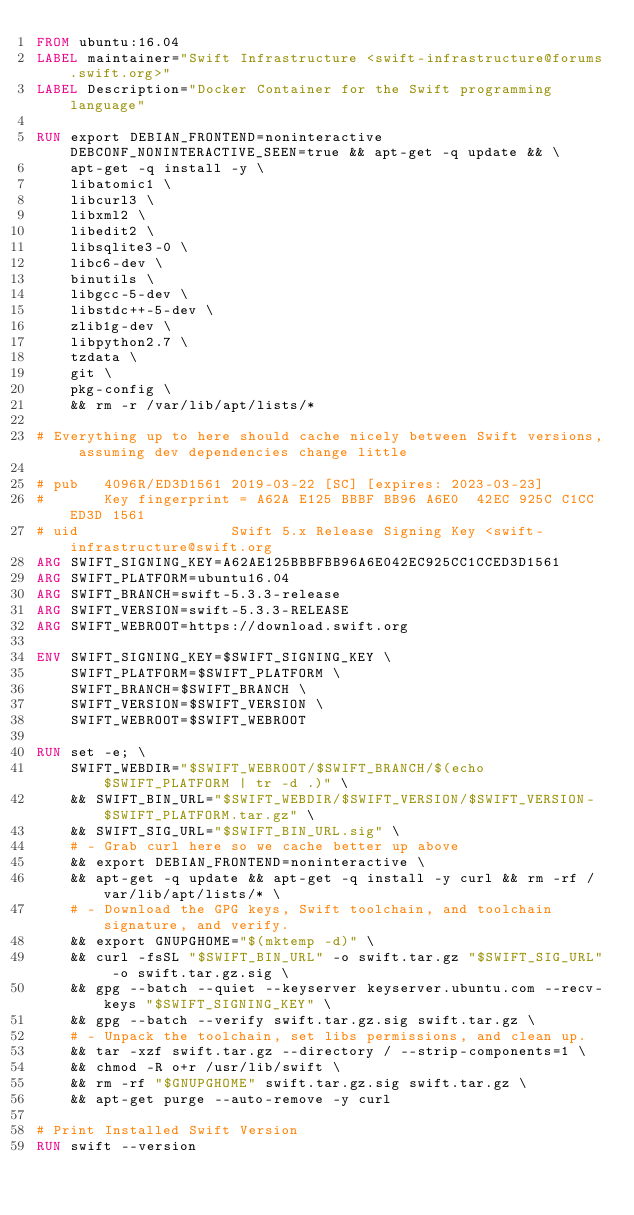<code> <loc_0><loc_0><loc_500><loc_500><_Dockerfile_>FROM ubuntu:16.04
LABEL maintainer="Swift Infrastructure <swift-infrastructure@forums.swift.org>"
LABEL Description="Docker Container for the Swift programming language"

RUN export DEBIAN_FRONTEND=noninteractive DEBCONF_NONINTERACTIVE_SEEN=true && apt-get -q update && \
    apt-get -q install -y \
    libatomic1 \
    libcurl3 \
    libxml2 \
    libedit2 \
    libsqlite3-0 \
    libc6-dev \
    binutils \
    libgcc-5-dev \
    libstdc++-5-dev \
    zlib1g-dev \
    libpython2.7 \
    tzdata \
    git \
    pkg-config \
    && rm -r /var/lib/apt/lists/*

# Everything up to here should cache nicely between Swift versions, assuming dev dependencies change little

# pub   4096R/ED3D1561 2019-03-22 [SC] [expires: 2023-03-23]
#       Key fingerprint = A62A E125 BBBF BB96 A6E0  42EC 925C C1CC ED3D 1561
# uid                  Swift 5.x Release Signing Key <swift-infrastructure@swift.org
ARG SWIFT_SIGNING_KEY=A62AE125BBBFBB96A6E042EC925CC1CCED3D1561
ARG SWIFT_PLATFORM=ubuntu16.04
ARG SWIFT_BRANCH=swift-5.3.3-release
ARG SWIFT_VERSION=swift-5.3.3-RELEASE
ARG SWIFT_WEBROOT=https://download.swift.org

ENV SWIFT_SIGNING_KEY=$SWIFT_SIGNING_KEY \
    SWIFT_PLATFORM=$SWIFT_PLATFORM \
    SWIFT_BRANCH=$SWIFT_BRANCH \
    SWIFT_VERSION=$SWIFT_VERSION \
    SWIFT_WEBROOT=$SWIFT_WEBROOT

RUN set -e; \
    SWIFT_WEBDIR="$SWIFT_WEBROOT/$SWIFT_BRANCH/$(echo $SWIFT_PLATFORM | tr -d .)" \
    && SWIFT_BIN_URL="$SWIFT_WEBDIR/$SWIFT_VERSION/$SWIFT_VERSION-$SWIFT_PLATFORM.tar.gz" \
    && SWIFT_SIG_URL="$SWIFT_BIN_URL.sig" \
    # - Grab curl here so we cache better up above
    && export DEBIAN_FRONTEND=noninteractive \
    && apt-get -q update && apt-get -q install -y curl && rm -rf /var/lib/apt/lists/* \
    # - Download the GPG keys, Swift toolchain, and toolchain signature, and verify.
    && export GNUPGHOME="$(mktemp -d)" \
    && curl -fsSL "$SWIFT_BIN_URL" -o swift.tar.gz "$SWIFT_SIG_URL" -o swift.tar.gz.sig \
    && gpg --batch --quiet --keyserver keyserver.ubuntu.com --recv-keys "$SWIFT_SIGNING_KEY" \
    && gpg --batch --verify swift.tar.gz.sig swift.tar.gz \
    # - Unpack the toolchain, set libs permissions, and clean up.
    && tar -xzf swift.tar.gz --directory / --strip-components=1 \
    && chmod -R o+r /usr/lib/swift \
    && rm -rf "$GNUPGHOME" swift.tar.gz.sig swift.tar.gz \
    && apt-get purge --auto-remove -y curl

# Print Installed Swift Version
RUN swift --version
</code> 